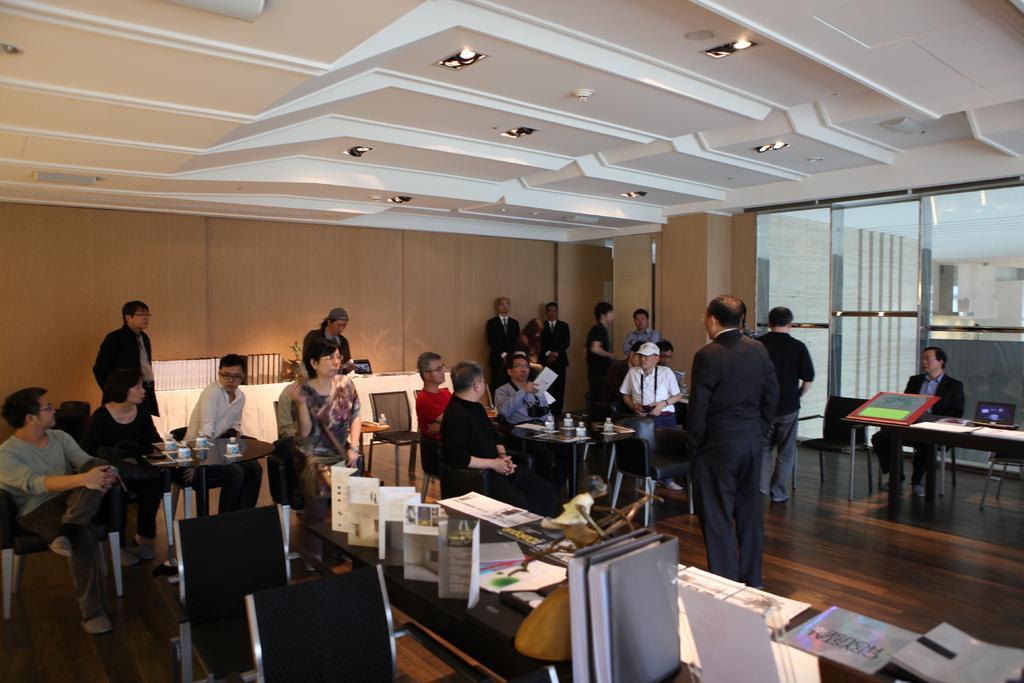In one or two sentences, can you explain what this image depicts? This is a picture taken in a room, there are a group of people some people are sitting on chairs and some people are standing on floor. In front of these people there is a table on the table there are bottles, paper, files and laptop. Behind the people there is a wall and a glass wind and there are ceiling lights on the top. 